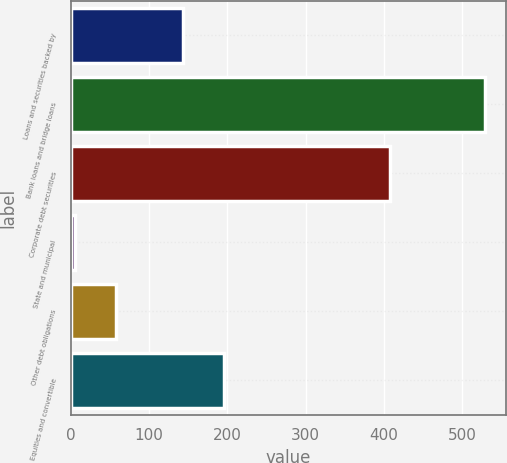Convert chart to OTSL. <chart><loc_0><loc_0><loc_500><loc_500><bar_chart><fcel>Loans and securities backed by<fcel>Bank loans and bridge loans<fcel>Corporate debt securities<fcel>State and municipal<fcel>Other debt obligations<fcel>Equities and convertible<nl><fcel>143<fcel>529<fcel>407<fcel>6<fcel>58.3<fcel>195.3<nl></chart> 